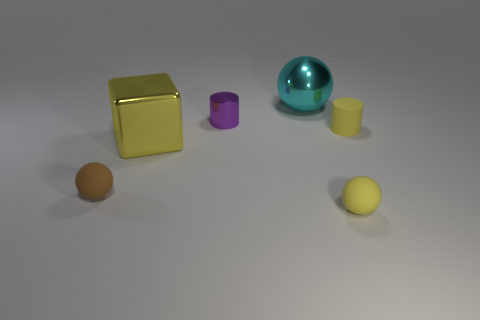The matte cylinder that is the same size as the yellow ball is what color?
Give a very brief answer. Yellow. Are there the same number of yellow blocks on the left side of the purple cylinder and tiny balls behind the cube?
Offer a very short reply. No. What is the sphere that is in front of the thing to the left of the block made of?
Keep it short and to the point. Rubber. How many objects are big cyan matte objects or yellow shiny things?
Ensure brevity in your answer.  1. What size is the cylinder that is the same color as the cube?
Give a very brief answer. Small. Is the number of cyan objects less than the number of tiny cylinders?
Ensure brevity in your answer.  Yes. What size is the purple cylinder that is the same material as the big cyan sphere?
Your answer should be compact. Small. What size is the cyan shiny object?
Offer a terse response. Large. There is a big yellow metallic object; what shape is it?
Offer a very short reply. Cube. There is a tiny rubber object on the left side of the big cyan thing; does it have the same color as the small rubber cylinder?
Provide a succinct answer. No. 